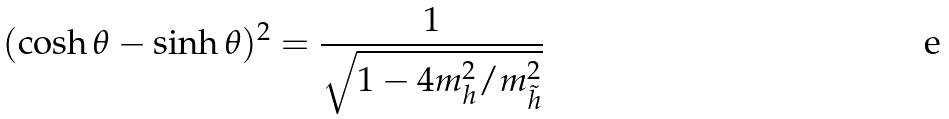<formula> <loc_0><loc_0><loc_500><loc_500>( \cosh \theta - \sinh \theta ) ^ { 2 } = \frac { 1 } { \sqrt { 1 - 4 m ^ { 2 } _ { h } / m ^ { 2 } _ { \tilde { h } } } } \,</formula> 